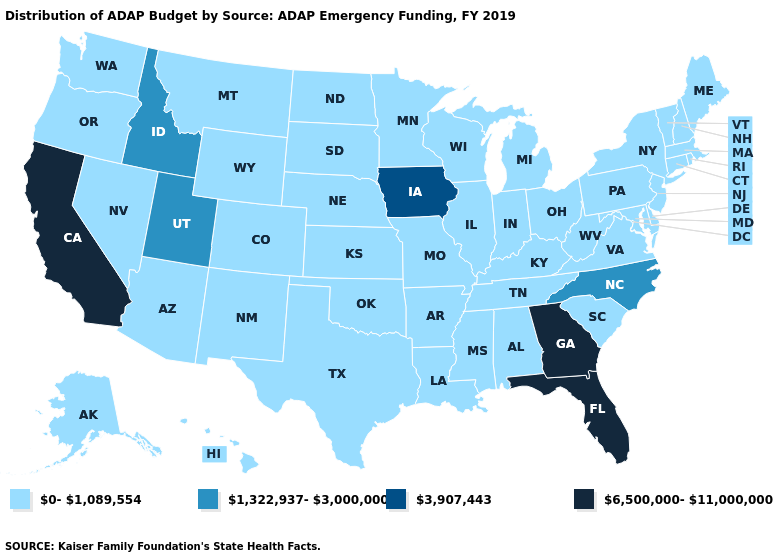Name the states that have a value in the range 0-1,089,554?
Keep it brief. Alabama, Alaska, Arizona, Arkansas, Colorado, Connecticut, Delaware, Hawaii, Illinois, Indiana, Kansas, Kentucky, Louisiana, Maine, Maryland, Massachusetts, Michigan, Minnesota, Mississippi, Missouri, Montana, Nebraska, Nevada, New Hampshire, New Jersey, New Mexico, New York, North Dakota, Ohio, Oklahoma, Oregon, Pennsylvania, Rhode Island, South Carolina, South Dakota, Tennessee, Texas, Vermont, Virginia, Washington, West Virginia, Wisconsin, Wyoming. Name the states that have a value in the range 1,322,937-3,000,000?
Write a very short answer. Idaho, North Carolina, Utah. What is the highest value in states that border New Mexico?
Short answer required. 1,322,937-3,000,000. What is the value of Utah?
Be succinct. 1,322,937-3,000,000. Does Iowa have the lowest value in the MidWest?
Write a very short answer. No. Which states have the highest value in the USA?
Write a very short answer. California, Florida, Georgia. Which states have the lowest value in the MidWest?
Quick response, please. Illinois, Indiana, Kansas, Michigan, Minnesota, Missouri, Nebraska, North Dakota, Ohio, South Dakota, Wisconsin. What is the value of Tennessee?
Give a very brief answer. 0-1,089,554. Does Texas have the lowest value in the South?
Keep it brief. Yes. What is the lowest value in states that border Nebraska?
Be succinct. 0-1,089,554. What is the value of New Hampshire?
Write a very short answer. 0-1,089,554. What is the lowest value in the Northeast?
Give a very brief answer. 0-1,089,554. Does the first symbol in the legend represent the smallest category?
Keep it brief. Yes. Is the legend a continuous bar?
Short answer required. No. 